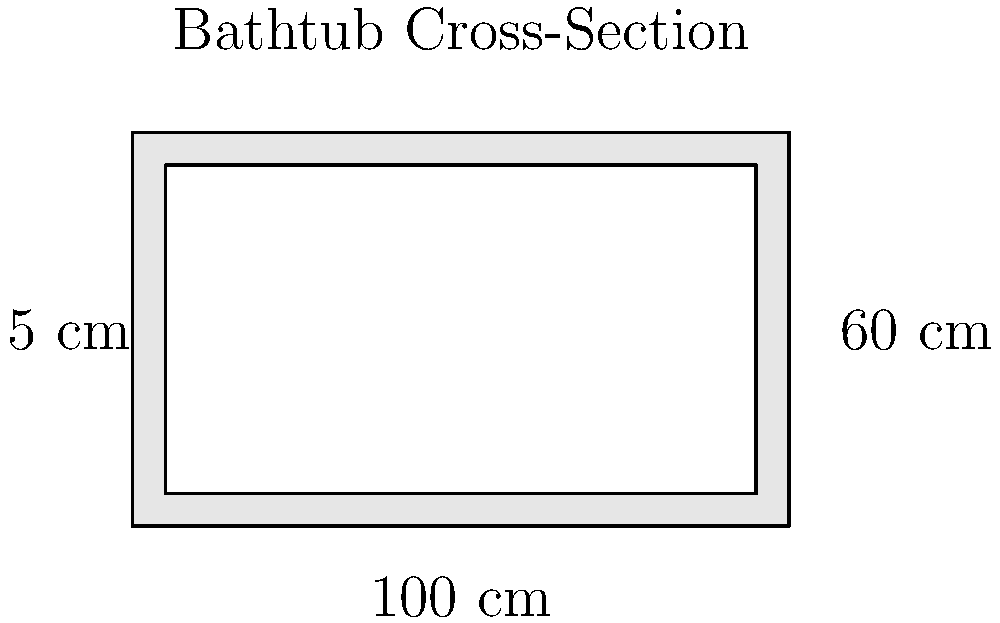Your old bathtub measures 100 cm long, 60 cm wide, and has a uniform depth of 40 cm. The walls and bottom are 5 cm thick. What is the total surface area (in square meters) of the inner part of the bathtub that needs refinishing? To calculate the surface area of the inner part of the bathtub, we need to consider all the surfaces that need refinishing:

1. Calculate the inner dimensions:
   Length: $100 - (2 \times 5) = 90$ cm
   Width: $60 - (2 \times 5) = 50$ cm
   Depth: $40 - 5 = 35$ cm

2. Calculate the area of each surface:
   a) Bottom: $90 \times 50 = 4500$ cm²
   b) Two long sides: $2 \times (90 \times 35) = 6300$ cm²
   c) Two short sides: $2 \times (50 \times 35) = 3500$ cm²

3. Sum up all the areas:
   Total area = $4500 + 6300 + 3500 = 14300$ cm²

4. Convert to square meters:
   $14300$ cm² $= 1.43$ m²

Therefore, the total surface area of the inner part of the bathtub that needs refinishing is 1.43 square meters.
Answer: 1.43 m² 